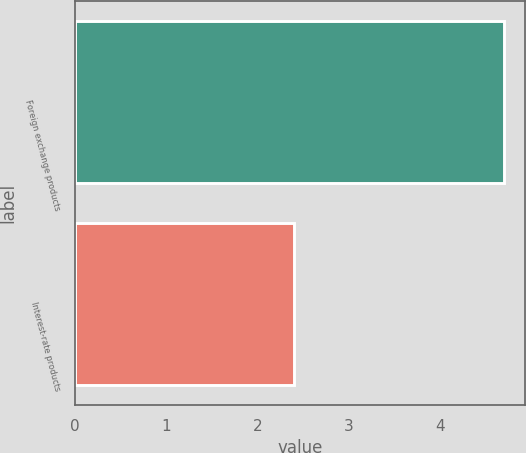Convert chart to OTSL. <chart><loc_0><loc_0><loc_500><loc_500><bar_chart><fcel>Foreign exchange products<fcel>Interest-rate products<nl><fcel>4.7<fcel>2.4<nl></chart> 